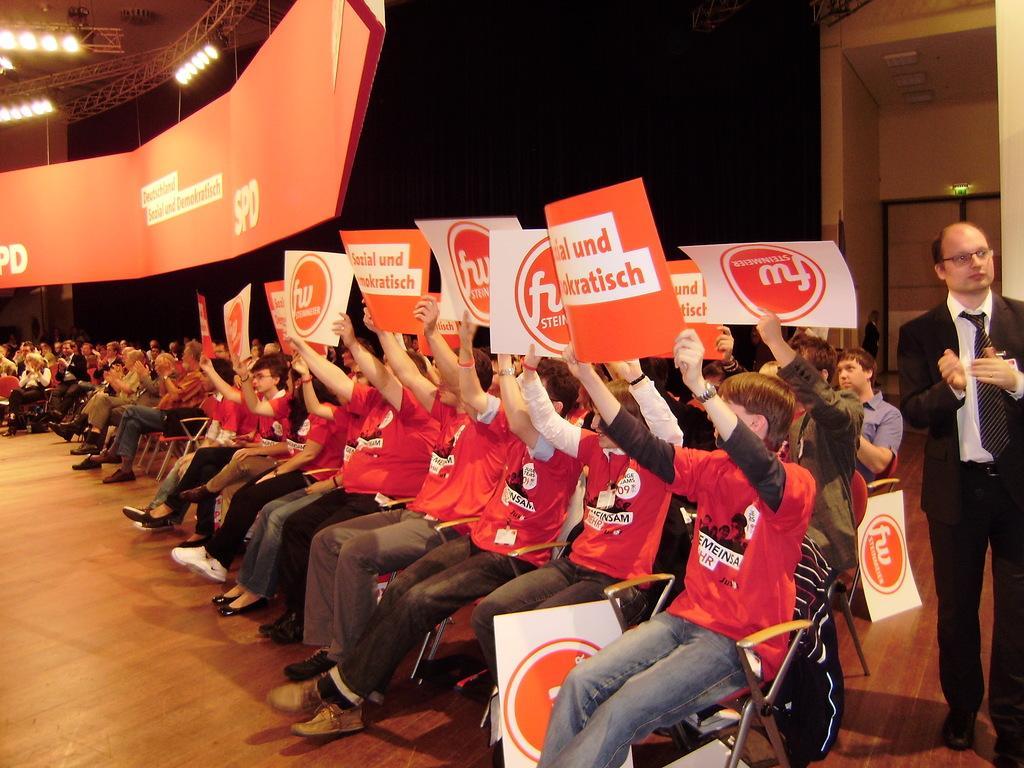Can you describe this image briefly? This image consists of some persons. They are sitting on chairs. They are holding some cards. There are lights at the top. 